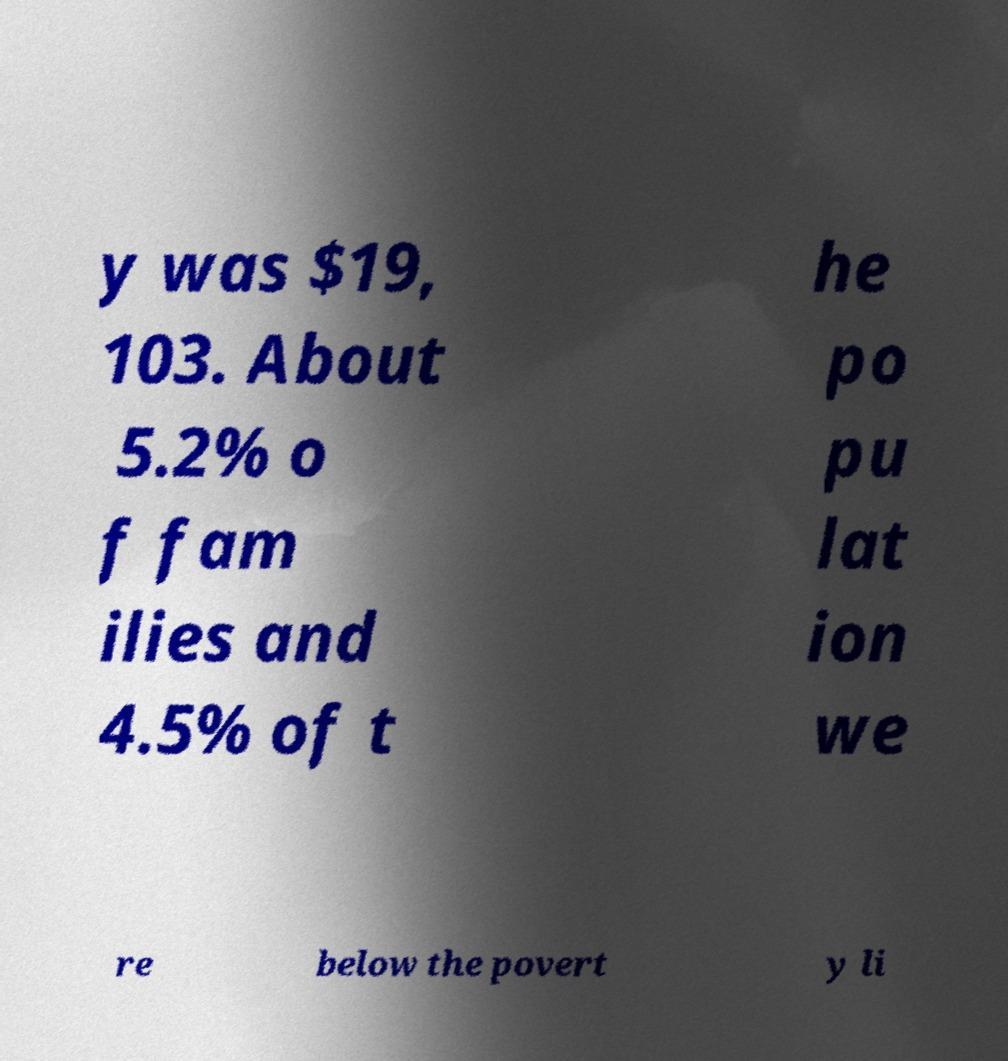Please read and relay the text visible in this image. What does it say? y was $19, 103. About 5.2% o f fam ilies and 4.5% of t he po pu lat ion we re below the povert y li 